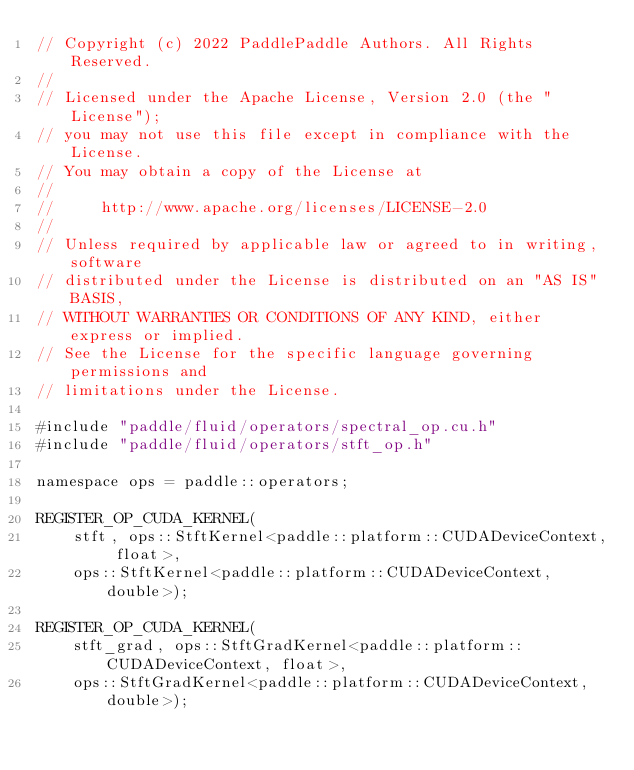<code> <loc_0><loc_0><loc_500><loc_500><_Cuda_>// Copyright (c) 2022 PaddlePaddle Authors. All Rights Reserved.
//
// Licensed under the Apache License, Version 2.0 (the "License");
// you may not use this file except in compliance with the License.
// You may obtain a copy of the License at
//
//     http://www.apache.org/licenses/LICENSE-2.0
//
// Unless required by applicable law or agreed to in writing, software
// distributed under the License is distributed on an "AS IS" BASIS,
// WITHOUT WARRANTIES OR CONDITIONS OF ANY KIND, either express or implied.
// See the License for the specific language governing permissions and
// limitations under the License.

#include "paddle/fluid/operators/spectral_op.cu.h"
#include "paddle/fluid/operators/stft_op.h"

namespace ops = paddle::operators;

REGISTER_OP_CUDA_KERNEL(
    stft, ops::StftKernel<paddle::platform::CUDADeviceContext, float>,
    ops::StftKernel<paddle::platform::CUDADeviceContext, double>);

REGISTER_OP_CUDA_KERNEL(
    stft_grad, ops::StftGradKernel<paddle::platform::CUDADeviceContext, float>,
    ops::StftGradKernel<paddle::platform::CUDADeviceContext, double>);
</code> 